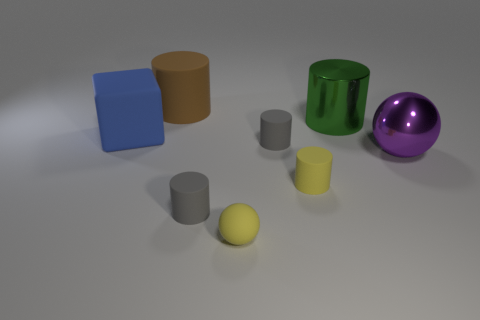What material do the objects seem to be made out of? Most objects have a matte finish suggesting they might be made of plastic, but the purple sphere's high shine hints at a metallic or glass material. 